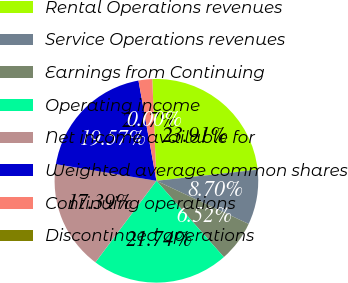Convert chart. <chart><loc_0><loc_0><loc_500><loc_500><pie_chart><fcel>Rental Operations revenues<fcel>Service Operations revenues<fcel>Earnings from Continuing<fcel>Operating income<fcel>Net income available for<fcel>Weighted average common shares<fcel>Continuing operations<fcel>Discontinued operations<nl><fcel>23.91%<fcel>8.7%<fcel>6.52%<fcel>21.74%<fcel>17.39%<fcel>19.57%<fcel>2.17%<fcel>0.0%<nl></chart> 